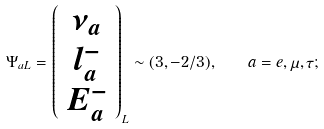<formula> <loc_0><loc_0><loc_500><loc_500>\Psi _ { a L } = \left ( \begin{array} { c } \nu _ { a } \\ l ^ { - } _ { a } \\ E ^ { - } _ { a } \end{array} \right ) _ { L } \sim ( { 3 } , - 2 / 3 ) , \quad a = e , \mu , \tau ;</formula> 